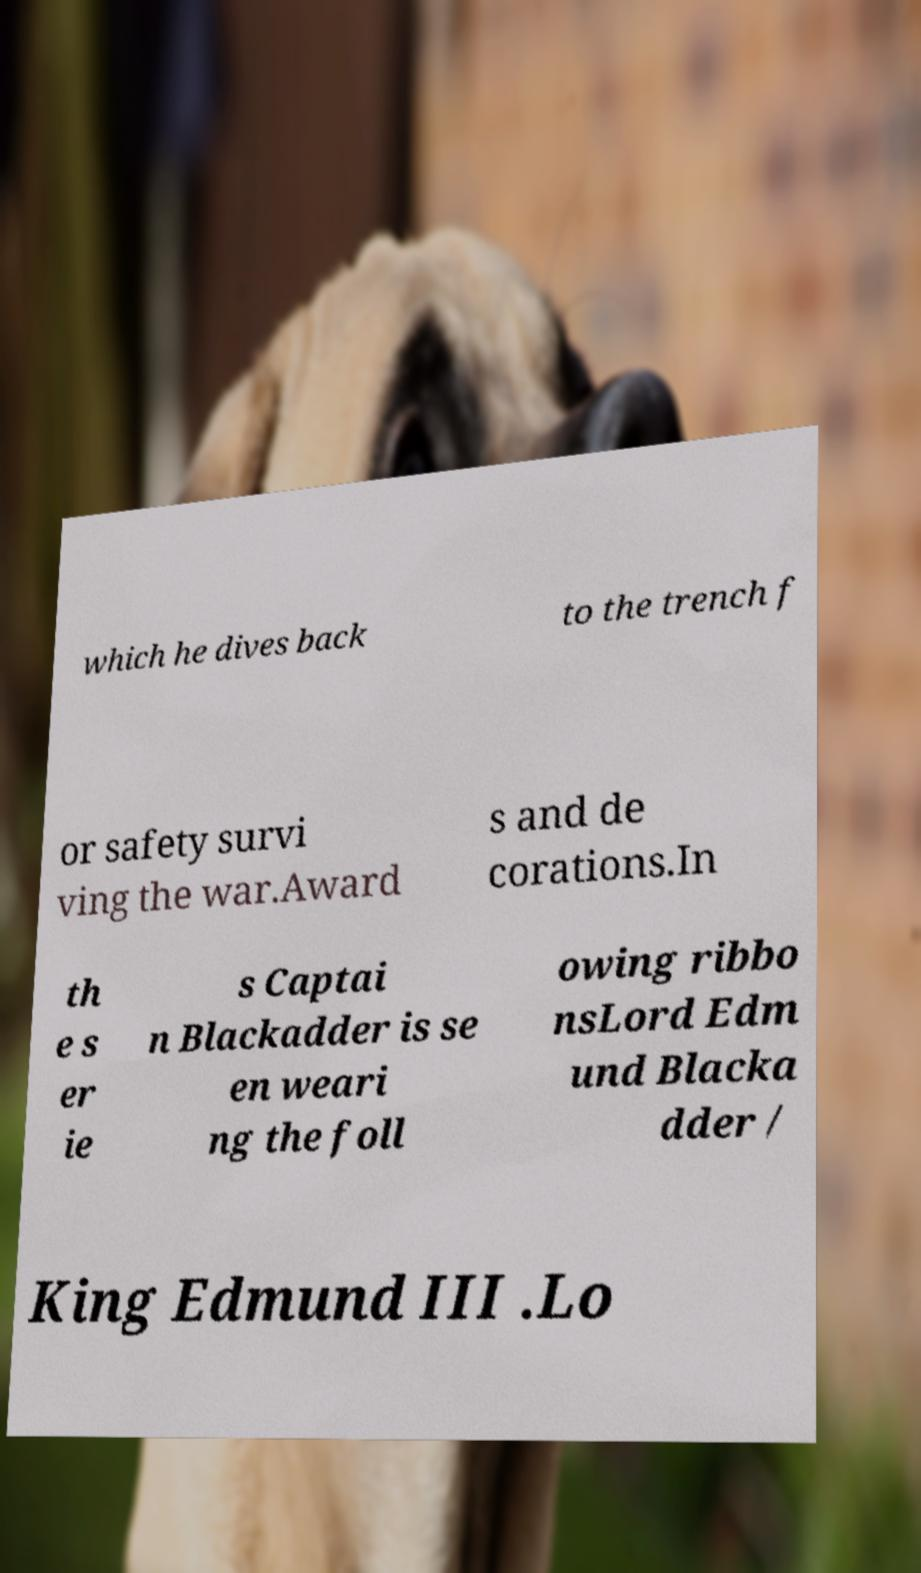Could you extract and type out the text from this image? which he dives back to the trench f or safety survi ving the war.Award s and de corations.In th e s er ie s Captai n Blackadder is se en weari ng the foll owing ribbo nsLord Edm und Blacka dder / King Edmund III .Lo 